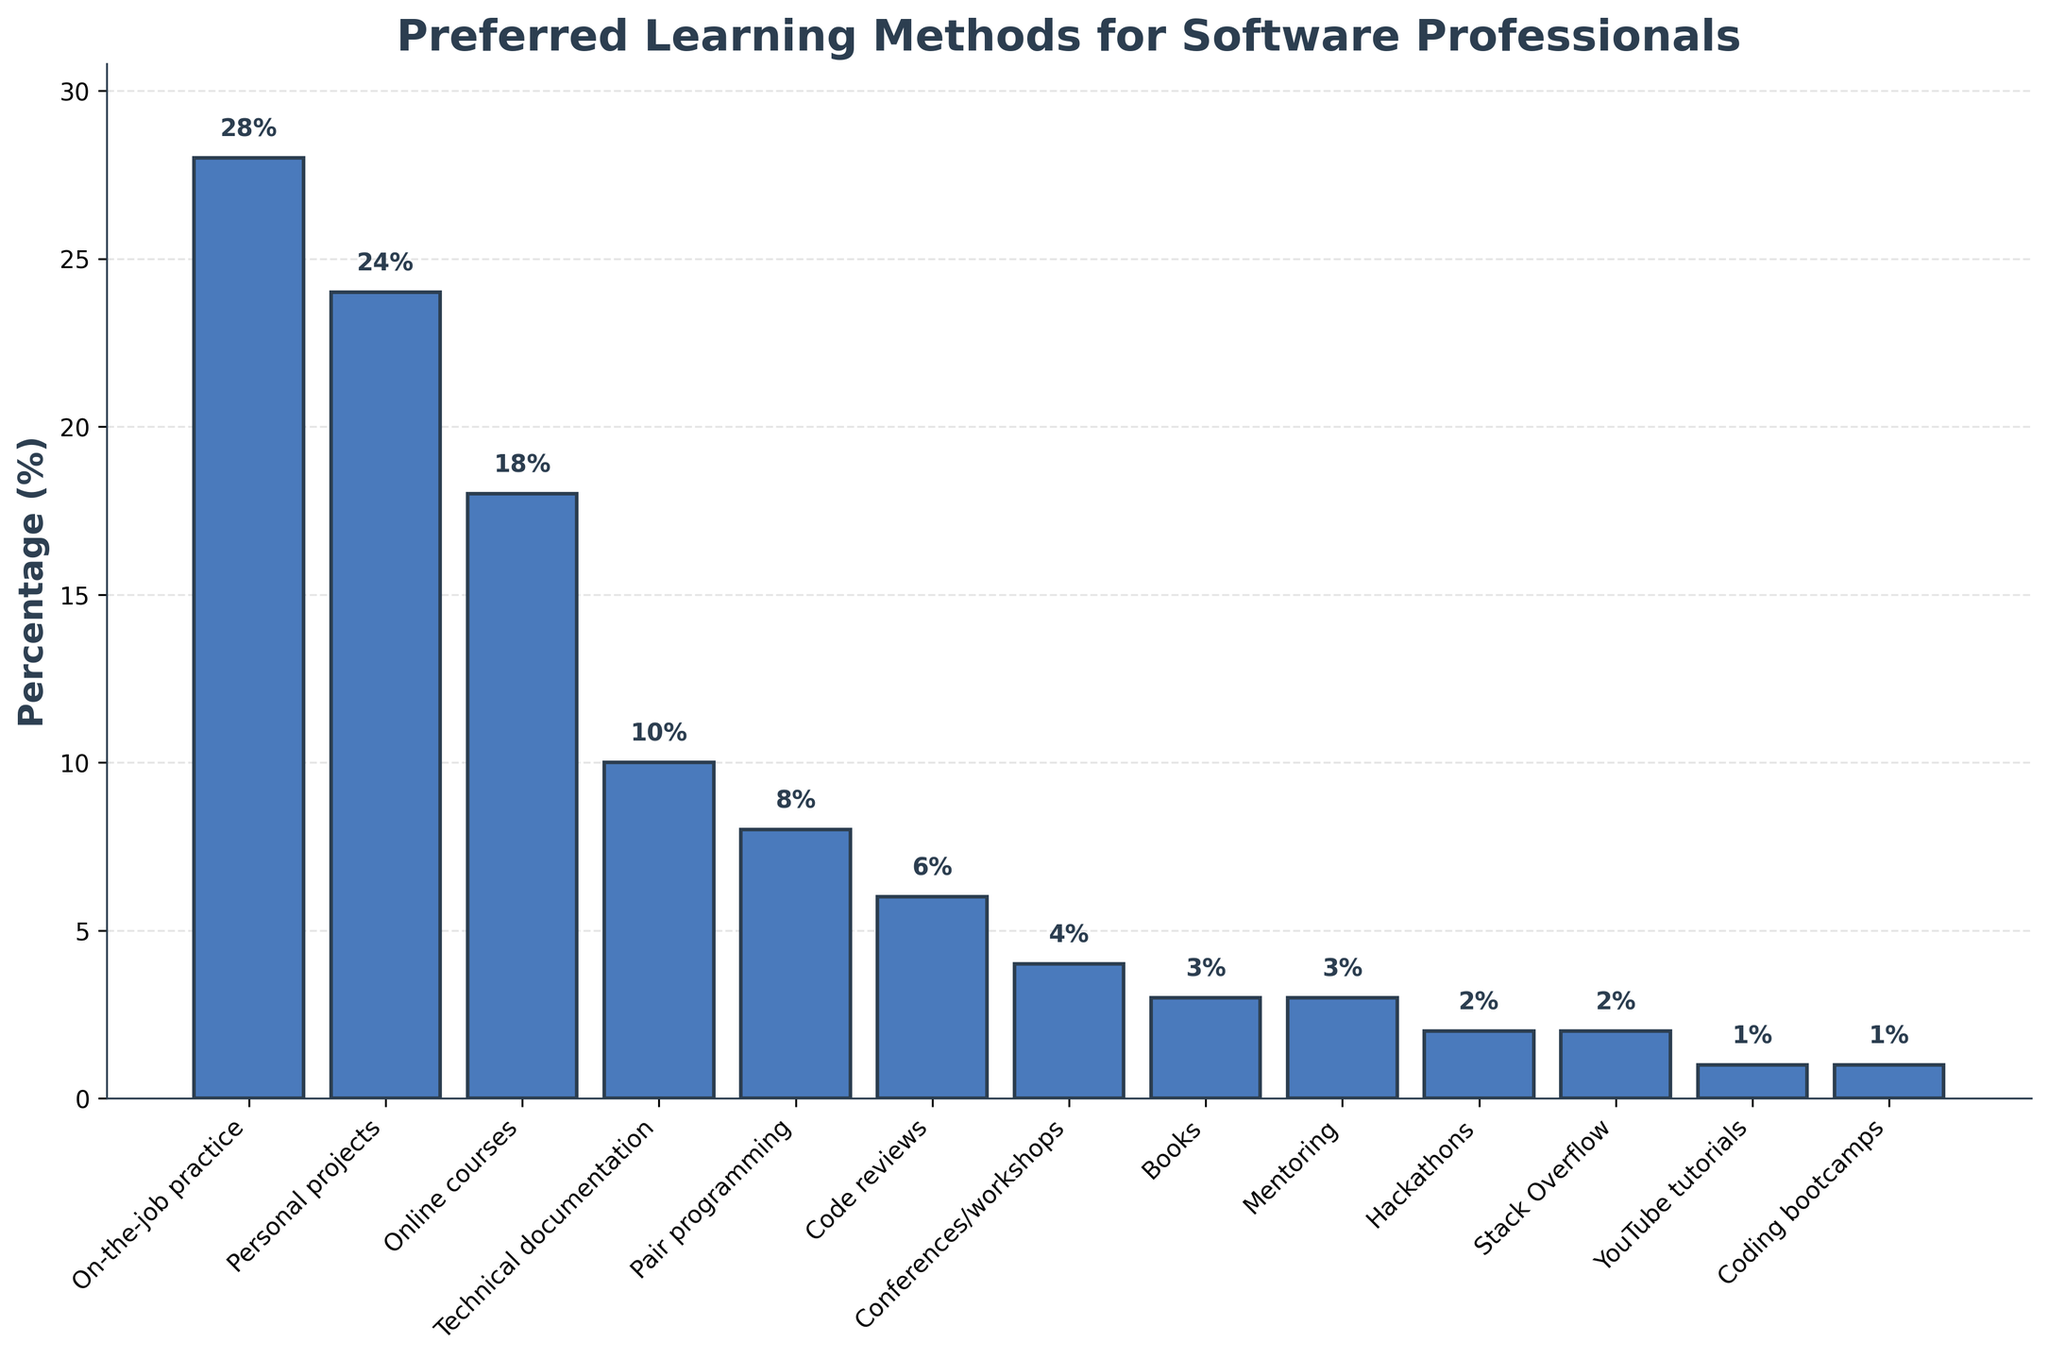Which learning method has the highest percentage? The highest bar in the chart represents the learning method with the highest percentage. Here, "On-the-job practice" has the highest percentage bar at 28%.
Answer: On-the-job practice Which learning method is preferred by 24% of the respondents? Find the bar labeled with a value of 24% and refer to its corresponding learning method. Here, "Personal projects" is preferred by 24% of the respondents.
Answer: Personal projects How much higher is the percentage of "Online courses" compared to "Books"? Find the percentages for "Online courses" (18%) and "Books" (3%). Subtract the smaller percentage from the larger one: 18% - 3% = 15%.
Answer: 15% Which two learning methods are used by the same percentage of respondents, and what is that percentage? Look for bars with identical heights that share the same percentage value. Here, "Books" and "Mentoring" both have a percentage of 3%.
Answer: Books and Mentoring; 3% What is the combined percentage of respondents who prefer "Pair programming" and "Code reviews"? Add the percentages for "Pair programming" (8%) and "Code reviews" (6%): 8% + 6% = 14%.
Answer: 14% Which learning method has the smallest percentage of respondents? Identify the shortest bar in the chart. Here, "YouTube tutorials" and "Coding bootcamps" both have the smallest percentage of 1%.
Answer: YouTube tutorials and Coding bootcamps What proportion of respondents prefer either "Hackathons" or "Stack Overflow"? Add the percentages for "Hackathons" (2%) and "Stack Overflow" (2%): 2% + 2% = 4%.
Answer: 4% By what percentage is "Technical documentation" less preferred than "Online courses"? Find the percentages for "Technical documentation" (10%) and "Online courses" (18%). Subtract the smaller percentage from the larger one: 18% - 10% = 8%.
Answer: 8% Which category of learning methods has slightly more followers, "Conferences/workshops" or "Books"? Compare the heights of the bars for "Conferences/workshops" (4%) and "Books" (3%). "Conferences/workshops" has a slightly higher percentage.
Answer: Conferences/workshops What is the combined percentage of respondents who prefer "On-the-job practice," "Personal projects," and "Online courses"? Add the percentages for "On-the-job practice" (28%), "Personal projects" (24%), and "Online courses" (18%): 28% + 24% + 18% = 70%.
Answer: 70% 